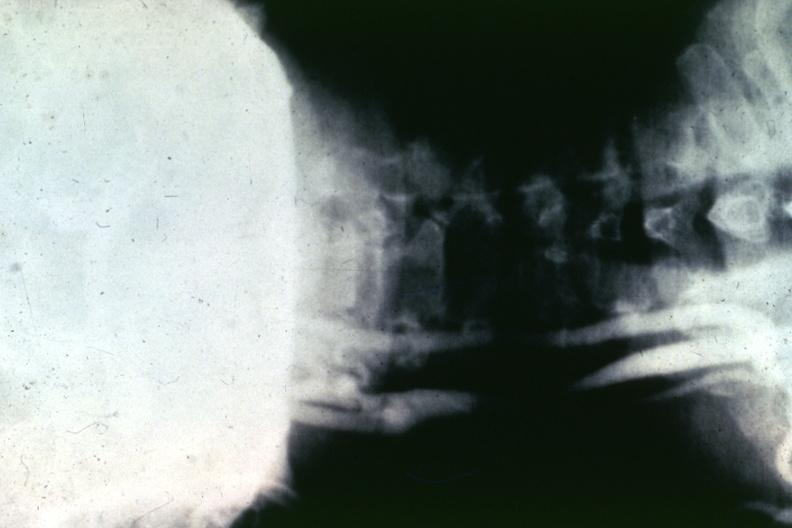does this image show artery?
Answer the question using a single word or phrase. Yes 